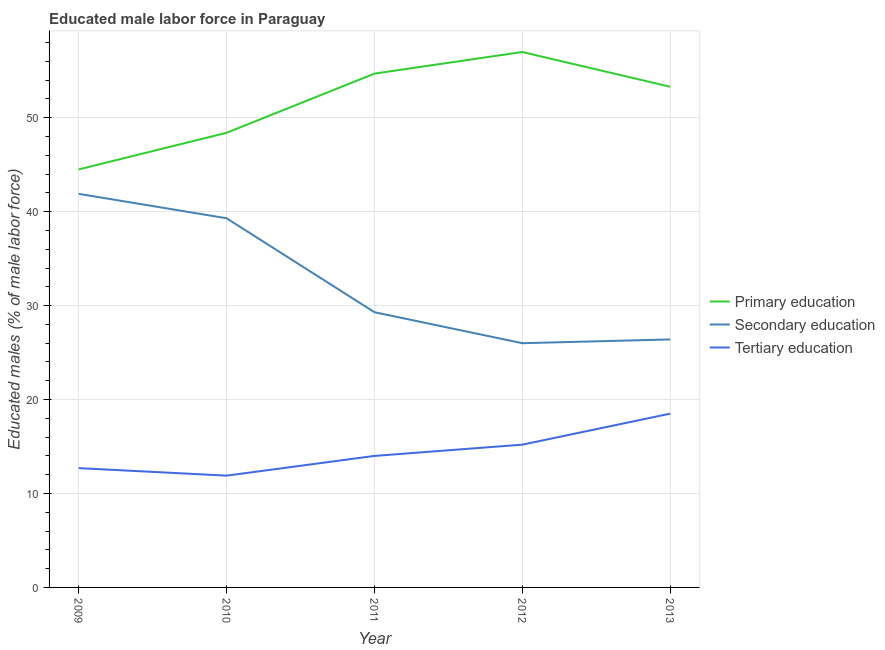What is the percentage of male labor force who received primary education in 2013?
Ensure brevity in your answer.  53.3. Across all years, what is the minimum percentage of male labor force who received tertiary education?
Provide a succinct answer. 11.9. In which year was the percentage of male labor force who received primary education minimum?
Your answer should be compact. 2009. What is the total percentage of male labor force who received primary education in the graph?
Make the answer very short. 257.9. What is the difference between the percentage of male labor force who received primary education in 2012 and that in 2013?
Offer a terse response. 3.7. What is the difference between the percentage of male labor force who received primary education in 2012 and the percentage of male labor force who received secondary education in 2009?
Make the answer very short. 15.1. What is the average percentage of male labor force who received primary education per year?
Make the answer very short. 51.58. In the year 2011, what is the difference between the percentage of male labor force who received secondary education and percentage of male labor force who received tertiary education?
Keep it short and to the point. 15.3. In how many years, is the percentage of male labor force who received tertiary education greater than 18 %?
Provide a short and direct response. 1. What is the ratio of the percentage of male labor force who received tertiary education in 2012 to that in 2013?
Give a very brief answer. 0.82. Is the percentage of male labor force who received primary education in 2009 less than that in 2011?
Provide a short and direct response. Yes. What is the difference between the highest and the second highest percentage of male labor force who received secondary education?
Your answer should be compact. 2.6. What is the difference between the highest and the lowest percentage of male labor force who received secondary education?
Give a very brief answer. 15.9. In how many years, is the percentage of male labor force who received primary education greater than the average percentage of male labor force who received primary education taken over all years?
Provide a succinct answer. 3. Is it the case that in every year, the sum of the percentage of male labor force who received primary education and percentage of male labor force who received secondary education is greater than the percentage of male labor force who received tertiary education?
Make the answer very short. Yes. Is the percentage of male labor force who received primary education strictly greater than the percentage of male labor force who received tertiary education over the years?
Provide a succinct answer. Yes. Is the percentage of male labor force who received primary education strictly less than the percentage of male labor force who received tertiary education over the years?
Provide a succinct answer. No. How many lines are there?
Ensure brevity in your answer.  3. Are the values on the major ticks of Y-axis written in scientific E-notation?
Your answer should be compact. No. Where does the legend appear in the graph?
Your answer should be compact. Center right. What is the title of the graph?
Offer a terse response. Educated male labor force in Paraguay. Does "Negligence towards kids" appear as one of the legend labels in the graph?
Ensure brevity in your answer.  No. What is the label or title of the Y-axis?
Provide a succinct answer. Educated males (% of male labor force). What is the Educated males (% of male labor force) of Primary education in 2009?
Give a very brief answer. 44.5. What is the Educated males (% of male labor force) in Secondary education in 2009?
Your answer should be compact. 41.9. What is the Educated males (% of male labor force) of Tertiary education in 2009?
Your answer should be very brief. 12.7. What is the Educated males (% of male labor force) of Primary education in 2010?
Give a very brief answer. 48.4. What is the Educated males (% of male labor force) in Secondary education in 2010?
Make the answer very short. 39.3. What is the Educated males (% of male labor force) in Tertiary education in 2010?
Offer a terse response. 11.9. What is the Educated males (% of male labor force) of Primary education in 2011?
Make the answer very short. 54.7. What is the Educated males (% of male labor force) of Secondary education in 2011?
Offer a terse response. 29.3. What is the Educated males (% of male labor force) in Tertiary education in 2011?
Keep it short and to the point. 14. What is the Educated males (% of male labor force) of Secondary education in 2012?
Offer a very short reply. 26. What is the Educated males (% of male labor force) of Tertiary education in 2012?
Your response must be concise. 15.2. What is the Educated males (% of male labor force) of Primary education in 2013?
Give a very brief answer. 53.3. What is the Educated males (% of male labor force) in Secondary education in 2013?
Offer a very short reply. 26.4. What is the Educated males (% of male labor force) of Tertiary education in 2013?
Provide a short and direct response. 18.5. Across all years, what is the maximum Educated males (% of male labor force) in Secondary education?
Offer a very short reply. 41.9. Across all years, what is the minimum Educated males (% of male labor force) in Primary education?
Offer a very short reply. 44.5. Across all years, what is the minimum Educated males (% of male labor force) of Tertiary education?
Provide a succinct answer. 11.9. What is the total Educated males (% of male labor force) of Primary education in the graph?
Ensure brevity in your answer.  257.9. What is the total Educated males (% of male labor force) of Secondary education in the graph?
Give a very brief answer. 162.9. What is the total Educated males (% of male labor force) in Tertiary education in the graph?
Provide a short and direct response. 72.3. What is the difference between the Educated males (% of male labor force) in Tertiary education in 2009 and that in 2010?
Offer a terse response. 0.8. What is the difference between the Educated males (% of male labor force) in Primary education in 2009 and that in 2011?
Make the answer very short. -10.2. What is the difference between the Educated males (% of male labor force) of Tertiary education in 2009 and that in 2011?
Provide a succinct answer. -1.3. What is the difference between the Educated males (% of male labor force) of Primary education in 2009 and that in 2013?
Ensure brevity in your answer.  -8.8. What is the difference between the Educated males (% of male labor force) in Primary education in 2010 and that in 2011?
Your response must be concise. -6.3. What is the difference between the Educated males (% of male labor force) in Tertiary education in 2010 and that in 2011?
Your response must be concise. -2.1. What is the difference between the Educated males (% of male labor force) in Primary education in 2010 and that in 2012?
Make the answer very short. -8.6. What is the difference between the Educated males (% of male labor force) of Primary education in 2010 and that in 2013?
Your answer should be compact. -4.9. What is the difference between the Educated males (% of male labor force) in Secondary education in 2010 and that in 2013?
Keep it short and to the point. 12.9. What is the difference between the Educated males (% of male labor force) of Primary education in 2011 and that in 2012?
Ensure brevity in your answer.  -2.3. What is the difference between the Educated males (% of male labor force) of Secondary education in 2011 and that in 2012?
Keep it short and to the point. 3.3. What is the difference between the Educated males (% of male labor force) in Tertiary education in 2011 and that in 2012?
Give a very brief answer. -1.2. What is the difference between the Educated males (% of male labor force) in Tertiary education in 2012 and that in 2013?
Your answer should be very brief. -3.3. What is the difference between the Educated males (% of male labor force) of Primary education in 2009 and the Educated males (% of male labor force) of Secondary education in 2010?
Ensure brevity in your answer.  5.2. What is the difference between the Educated males (% of male labor force) of Primary education in 2009 and the Educated males (% of male labor force) of Tertiary education in 2010?
Provide a succinct answer. 32.6. What is the difference between the Educated males (% of male labor force) in Secondary education in 2009 and the Educated males (% of male labor force) in Tertiary education in 2010?
Provide a short and direct response. 30. What is the difference between the Educated males (% of male labor force) of Primary education in 2009 and the Educated males (% of male labor force) of Tertiary education in 2011?
Keep it short and to the point. 30.5. What is the difference between the Educated males (% of male labor force) in Secondary education in 2009 and the Educated males (% of male labor force) in Tertiary education in 2011?
Provide a succinct answer. 27.9. What is the difference between the Educated males (% of male labor force) of Primary education in 2009 and the Educated males (% of male labor force) of Secondary education in 2012?
Provide a short and direct response. 18.5. What is the difference between the Educated males (% of male labor force) in Primary education in 2009 and the Educated males (% of male labor force) in Tertiary education in 2012?
Your response must be concise. 29.3. What is the difference between the Educated males (% of male labor force) of Secondary education in 2009 and the Educated males (% of male labor force) of Tertiary education in 2012?
Give a very brief answer. 26.7. What is the difference between the Educated males (% of male labor force) of Secondary education in 2009 and the Educated males (% of male labor force) of Tertiary education in 2013?
Provide a short and direct response. 23.4. What is the difference between the Educated males (% of male labor force) in Primary education in 2010 and the Educated males (% of male labor force) in Tertiary education in 2011?
Offer a very short reply. 34.4. What is the difference between the Educated males (% of male labor force) of Secondary education in 2010 and the Educated males (% of male labor force) of Tertiary education in 2011?
Ensure brevity in your answer.  25.3. What is the difference between the Educated males (% of male labor force) in Primary education in 2010 and the Educated males (% of male labor force) in Secondary education in 2012?
Offer a very short reply. 22.4. What is the difference between the Educated males (% of male labor force) of Primary education in 2010 and the Educated males (% of male labor force) of Tertiary education in 2012?
Ensure brevity in your answer.  33.2. What is the difference between the Educated males (% of male labor force) of Secondary education in 2010 and the Educated males (% of male labor force) of Tertiary education in 2012?
Your response must be concise. 24.1. What is the difference between the Educated males (% of male labor force) of Primary education in 2010 and the Educated males (% of male labor force) of Secondary education in 2013?
Your answer should be very brief. 22. What is the difference between the Educated males (% of male labor force) of Primary education in 2010 and the Educated males (% of male labor force) of Tertiary education in 2013?
Give a very brief answer. 29.9. What is the difference between the Educated males (% of male labor force) in Secondary education in 2010 and the Educated males (% of male labor force) in Tertiary education in 2013?
Offer a terse response. 20.8. What is the difference between the Educated males (% of male labor force) in Primary education in 2011 and the Educated males (% of male labor force) in Secondary education in 2012?
Provide a short and direct response. 28.7. What is the difference between the Educated males (% of male labor force) of Primary education in 2011 and the Educated males (% of male labor force) of Tertiary education in 2012?
Offer a very short reply. 39.5. What is the difference between the Educated males (% of male labor force) of Secondary education in 2011 and the Educated males (% of male labor force) of Tertiary education in 2012?
Your response must be concise. 14.1. What is the difference between the Educated males (% of male labor force) in Primary education in 2011 and the Educated males (% of male labor force) in Secondary education in 2013?
Give a very brief answer. 28.3. What is the difference between the Educated males (% of male labor force) of Primary education in 2011 and the Educated males (% of male labor force) of Tertiary education in 2013?
Ensure brevity in your answer.  36.2. What is the difference between the Educated males (% of male labor force) of Secondary education in 2011 and the Educated males (% of male labor force) of Tertiary education in 2013?
Give a very brief answer. 10.8. What is the difference between the Educated males (% of male labor force) in Primary education in 2012 and the Educated males (% of male labor force) in Secondary education in 2013?
Give a very brief answer. 30.6. What is the difference between the Educated males (% of male labor force) of Primary education in 2012 and the Educated males (% of male labor force) of Tertiary education in 2013?
Ensure brevity in your answer.  38.5. What is the difference between the Educated males (% of male labor force) in Secondary education in 2012 and the Educated males (% of male labor force) in Tertiary education in 2013?
Offer a very short reply. 7.5. What is the average Educated males (% of male labor force) in Primary education per year?
Provide a short and direct response. 51.58. What is the average Educated males (% of male labor force) of Secondary education per year?
Your answer should be compact. 32.58. What is the average Educated males (% of male labor force) in Tertiary education per year?
Provide a short and direct response. 14.46. In the year 2009, what is the difference between the Educated males (% of male labor force) in Primary education and Educated males (% of male labor force) in Tertiary education?
Offer a terse response. 31.8. In the year 2009, what is the difference between the Educated males (% of male labor force) in Secondary education and Educated males (% of male labor force) in Tertiary education?
Give a very brief answer. 29.2. In the year 2010, what is the difference between the Educated males (% of male labor force) of Primary education and Educated males (% of male labor force) of Secondary education?
Offer a terse response. 9.1. In the year 2010, what is the difference between the Educated males (% of male labor force) of Primary education and Educated males (% of male labor force) of Tertiary education?
Offer a very short reply. 36.5. In the year 2010, what is the difference between the Educated males (% of male labor force) of Secondary education and Educated males (% of male labor force) of Tertiary education?
Your response must be concise. 27.4. In the year 2011, what is the difference between the Educated males (% of male labor force) in Primary education and Educated males (% of male labor force) in Secondary education?
Provide a succinct answer. 25.4. In the year 2011, what is the difference between the Educated males (% of male labor force) of Primary education and Educated males (% of male labor force) of Tertiary education?
Your answer should be very brief. 40.7. In the year 2012, what is the difference between the Educated males (% of male labor force) in Primary education and Educated males (% of male labor force) in Secondary education?
Ensure brevity in your answer.  31. In the year 2012, what is the difference between the Educated males (% of male labor force) of Primary education and Educated males (% of male labor force) of Tertiary education?
Your answer should be compact. 41.8. In the year 2013, what is the difference between the Educated males (% of male labor force) in Primary education and Educated males (% of male labor force) in Secondary education?
Ensure brevity in your answer.  26.9. In the year 2013, what is the difference between the Educated males (% of male labor force) of Primary education and Educated males (% of male labor force) of Tertiary education?
Your answer should be compact. 34.8. In the year 2013, what is the difference between the Educated males (% of male labor force) in Secondary education and Educated males (% of male labor force) in Tertiary education?
Give a very brief answer. 7.9. What is the ratio of the Educated males (% of male labor force) in Primary education in 2009 to that in 2010?
Your answer should be compact. 0.92. What is the ratio of the Educated males (% of male labor force) of Secondary education in 2009 to that in 2010?
Your answer should be compact. 1.07. What is the ratio of the Educated males (% of male labor force) in Tertiary education in 2009 to that in 2010?
Make the answer very short. 1.07. What is the ratio of the Educated males (% of male labor force) of Primary education in 2009 to that in 2011?
Ensure brevity in your answer.  0.81. What is the ratio of the Educated males (% of male labor force) in Secondary education in 2009 to that in 2011?
Provide a succinct answer. 1.43. What is the ratio of the Educated males (% of male labor force) of Tertiary education in 2009 to that in 2011?
Your answer should be very brief. 0.91. What is the ratio of the Educated males (% of male labor force) of Primary education in 2009 to that in 2012?
Provide a short and direct response. 0.78. What is the ratio of the Educated males (% of male labor force) of Secondary education in 2009 to that in 2012?
Provide a short and direct response. 1.61. What is the ratio of the Educated males (% of male labor force) in Tertiary education in 2009 to that in 2012?
Keep it short and to the point. 0.84. What is the ratio of the Educated males (% of male labor force) in Primary education in 2009 to that in 2013?
Your answer should be very brief. 0.83. What is the ratio of the Educated males (% of male labor force) in Secondary education in 2009 to that in 2013?
Provide a succinct answer. 1.59. What is the ratio of the Educated males (% of male labor force) of Tertiary education in 2009 to that in 2013?
Your answer should be compact. 0.69. What is the ratio of the Educated males (% of male labor force) of Primary education in 2010 to that in 2011?
Provide a succinct answer. 0.88. What is the ratio of the Educated males (% of male labor force) in Secondary education in 2010 to that in 2011?
Your response must be concise. 1.34. What is the ratio of the Educated males (% of male labor force) of Tertiary education in 2010 to that in 2011?
Your answer should be very brief. 0.85. What is the ratio of the Educated males (% of male labor force) in Primary education in 2010 to that in 2012?
Provide a succinct answer. 0.85. What is the ratio of the Educated males (% of male labor force) in Secondary education in 2010 to that in 2012?
Provide a succinct answer. 1.51. What is the ratio of the Educated males (% of male labor force) in Tertiary education in 2010 to that in 2012?
Your answer should be compact. 0.78. What is the ratio of the Educated males (% of male labor force) in Primary education in 2010 to that in 2013?
Keep it short and to the point. 0.91. What is the ratio of the Educated males (% of male labor force) of Secondary education in 2010 to that in 2013?
Ensure brevity in your answer.  1.49. What is the ratio of the Educated males (% of male labor force) in Tertiary education in 2010 to that in 2013?
Keep it short and to the point. 0.64. What is the ratio of the Educated males (% of male labor force) in Primary education in 2011 to that in 2012?
Your answer should be compact. 0.96. What is the ratio of the Educated males (% of male labor force) of Secondary education in 2011 to that in 2012?
Your answer should be very brief. 1.13. What is the ratio of the Educated males (% of male labor force) of Tertiary education in 2011 to that in 2012?
Make the answer very short. 0.92. What is the ratio of the Educated males (% of male labor force) in Primary education in 2011 to that in 2013?
Provide a succinct answer. 1.03. What is the ratio of the Educated males (% of male labor force) of Secondary education in 2011 to that in 2013?
Give a very brief answer. 1.11. What is the ratio of the Educated males (% of male labor force) of Tertiary education in 2011 to that in 2013?
Keep it short and to the point. 0.76. What is the ratio of the Educated males (% of male labor force) in Primary education in 2012 to that in 2013?
Offer a very short reply. 1.07. What is the ratio of the Educated males (% of male labor force) of Secondary education in 2012 to that in 2013?
Offer a very short reply. 0.98. What is the ratio of the Educated males (% of male labor force) of Tertiary education in 2012 to that in 2013?
Offer a very short reply. 0.82. What is the difference between the highest and the second highest Educated males (% of male labor force) of Primary education?
Make the answer very short. 2.3. 